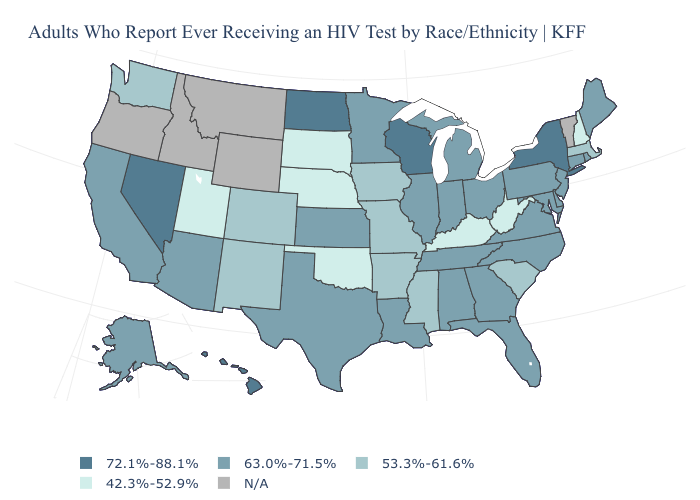Among the states that border North Carolina , does South Carolina have the lowest value?
Concise answer only. Yes. Which states hav the highest value in the Northeast?
Give a very brief answer. New York. Name the states that have a value in the range 53.3%-61.6%?
Be succinct. Arkansas, Colorado, Iowa, Massachusetts, Mississippi, Missouri, New Mexico, South Carolina, Washington. Among the states that border Minnesota , does North Dakota have the highest value?
Be succinct. Yes. Name the states that have a value in the range 63.0%-71.5%?
Short answer required. Alabama, Alaska, Arizona, California, Connecticut, Delaware, Florida, Georgia, Illinois, Indiana, Kansas, Louisiana, Maine, Maryland, Michigan, Minnesota, New Jersey, North Carolina, Ohio, Pennsylvania, Rhode Island, Tennessee, Texas, Virginia. Name the states that have a value in the range 72.1%-88.1%?
Give a very brief answer. Hawaii, Nevada, New York, North Dakota, Wisconsin. What is the lowest value in the South?
Be succinct. 42.3%-52.9%. Name the states that have a value in the range N/A?
Concise answer only. Idaho, Montana, Oregon, Vermont, Wyoming. Name the states that have a value in the range N/A?
Be succinct. Idaho, Montana, Oregon, Vermont, Wyoming. What is the highest value in the USA?
Answer briefly. 72.1%-88.1%. What is the value of California?
Keep it brief. 63.0%-71.5%. What is the value of New York?
Write a very short answer. 72.1%-88.1%. What is the highest value in the USA?
Write a very short answer. 72.1%-88.1%. Name the states that have a value in the range 72.1%-88.1%?
Give a very brief answer. Hawaii, Nevada, New York, North Dakota, Wisconsin. 